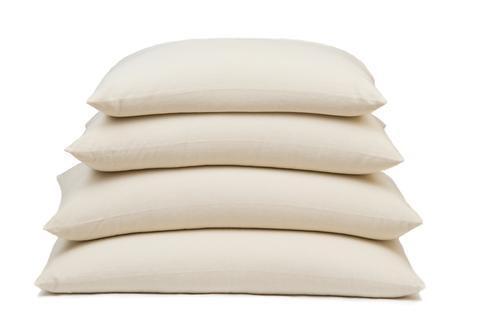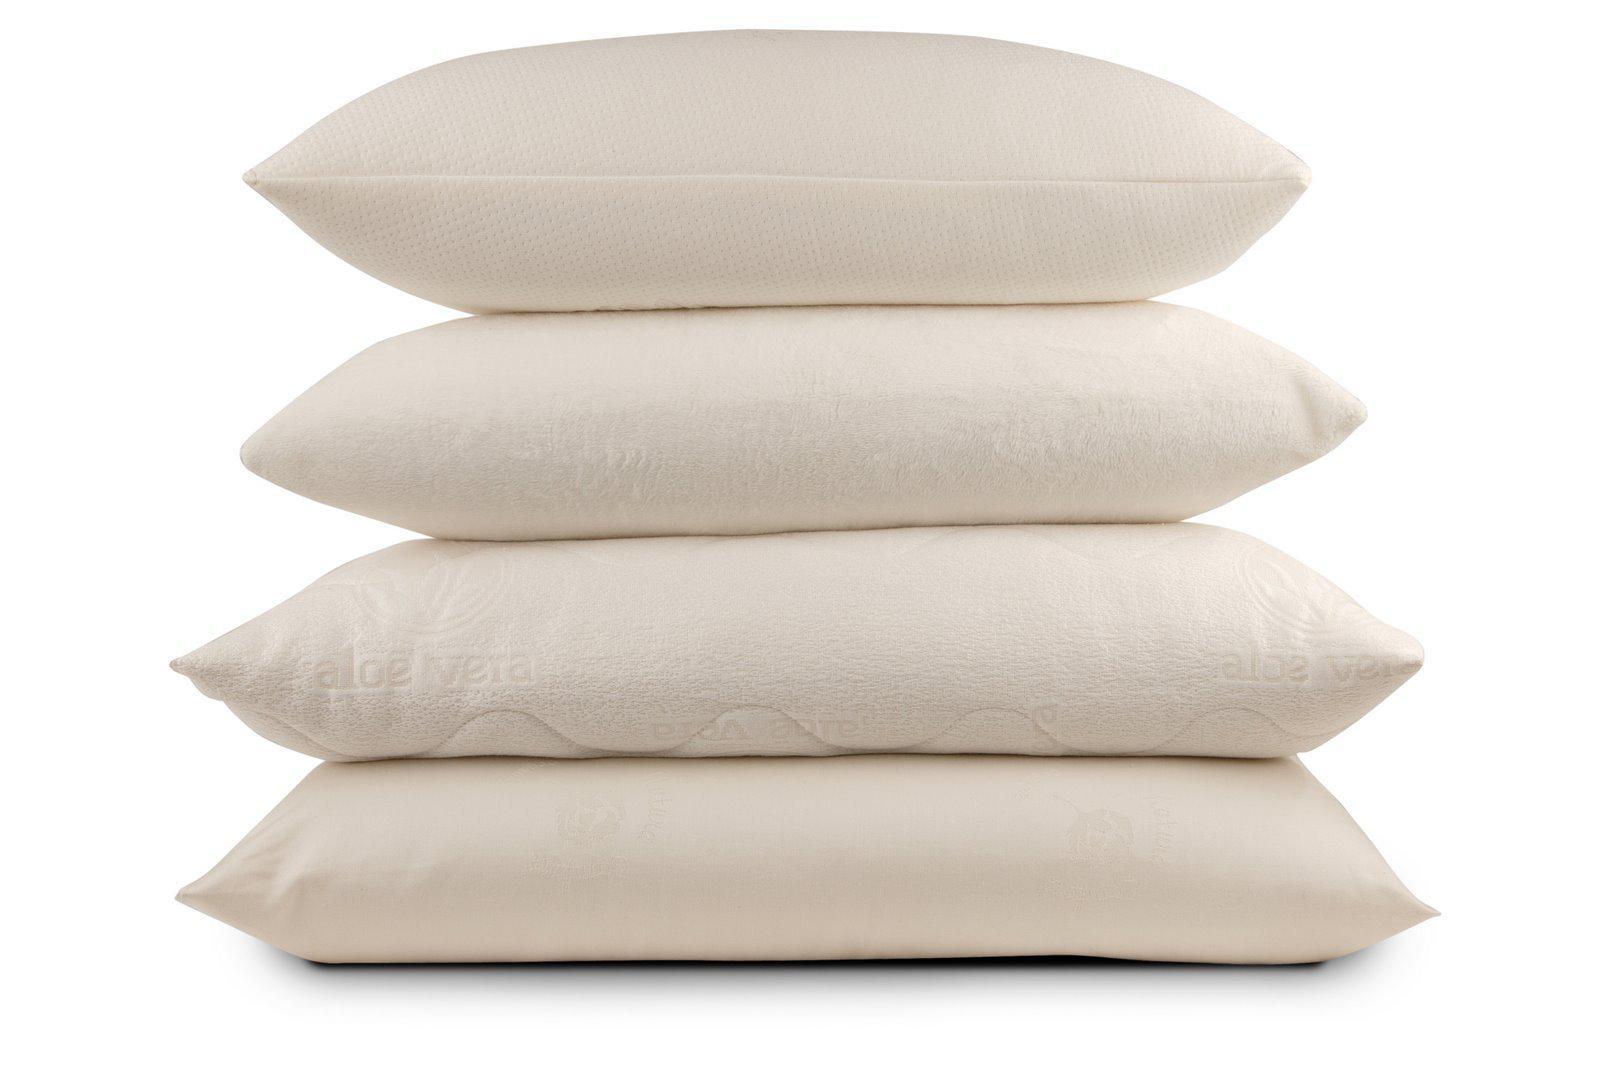The first image is the image on the left, the second image is the image on the right. For the images displayed, is the sentence "In one of the images, there are exactly six square pillows stacked on top of each other." factually correct? Answer yes or no. No. The first image is the image on the left, the second image is the image on the right. For the images shown, is this caption "The left image includes at least one square pillow with a dimensional embellishment, and the right image includes a stack of solid and patterned pillows." true? Answer yes or no. No. 